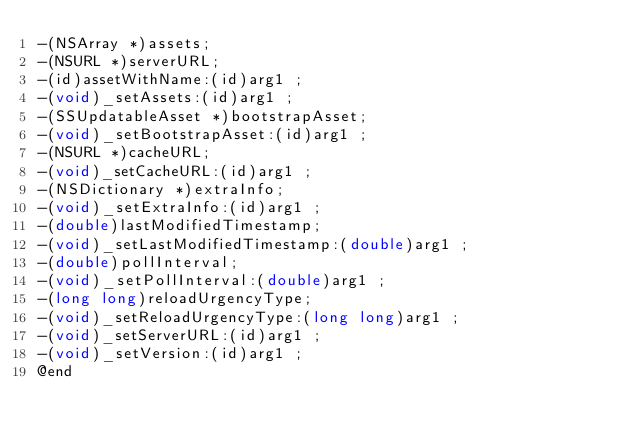<code> <loc_0><loc_0><loc_500><loc_500><_C_>-(NSArray *)assets;
-(NSURL *)serverURL;
-(id)assetWithName:(id)arg1 ;
-(void)_setAssets:(id)arg1 ;
-(SSUpdatableAsset *)bootstrapAsset;
-(void)_setBootstrapAsset:(id)arg1 ;
-(NSURL *)cacheURL;
-(void)_setCacheURL:(id)arg1 ;
-(NSDictionary *)extraInfo;
-(void)_setExtraInfo:(id)arg1 ;
-(double)lastModifiedTimestamp;
-(void)_setLastModifiedTimestamp:(double)arg1 ;
-(double)pollInterval;
-(void)_setPollInterval:(double)arg1 ;
-(long long)reloadUrgencyType;
-(void)_setReloadUrgencyType:(long long)arg1 ;
-(void)_setServerURL:(id)arg1 ;
-(void)_setVersion:(id)arg1 ;
@end

</code> 